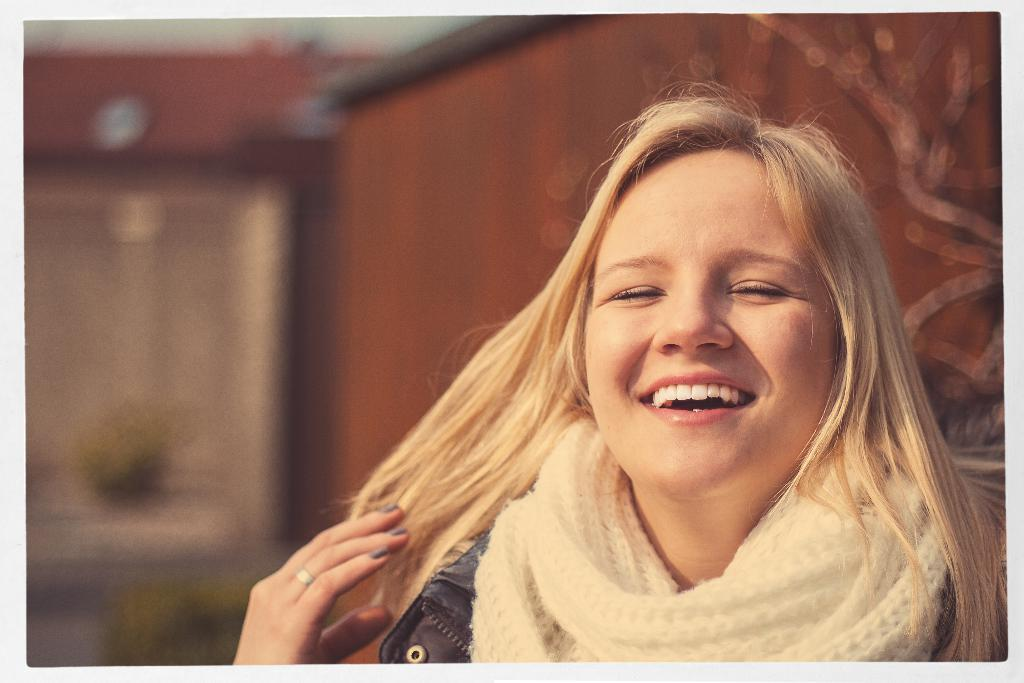Who is the main subject in the image? There is a girl in the image. Where is the girl located in the image? The girl is on the right side of the image. What is the girl doing in the image? The girl is laughing. Can you describe the background of the image? The background of the image is blurred. What type of can is visible in the image? There is no can present in the image. What is the weight of the mint in the image? There is no mint present in the image, so its weight cannot be determined. 